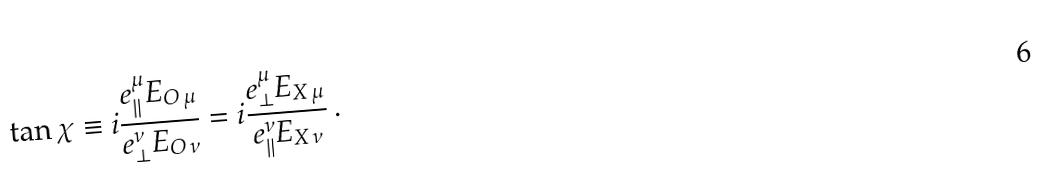<formula> <loc_0><loc_0><loc_500><loc_500>\tan \chi \equiv i \frac { e _ { \| } ^ { \mu } E _ { O \, \mu } } { e _ { \perp } ^ { \nu } E _ { O \, \nu } } = i \frac { e _ { \perp } ^ { \mu } E _ { X \, \mu } } { e _ { \| } ^ { \nu } E _ { X \, \nu } } \, .</formula> 